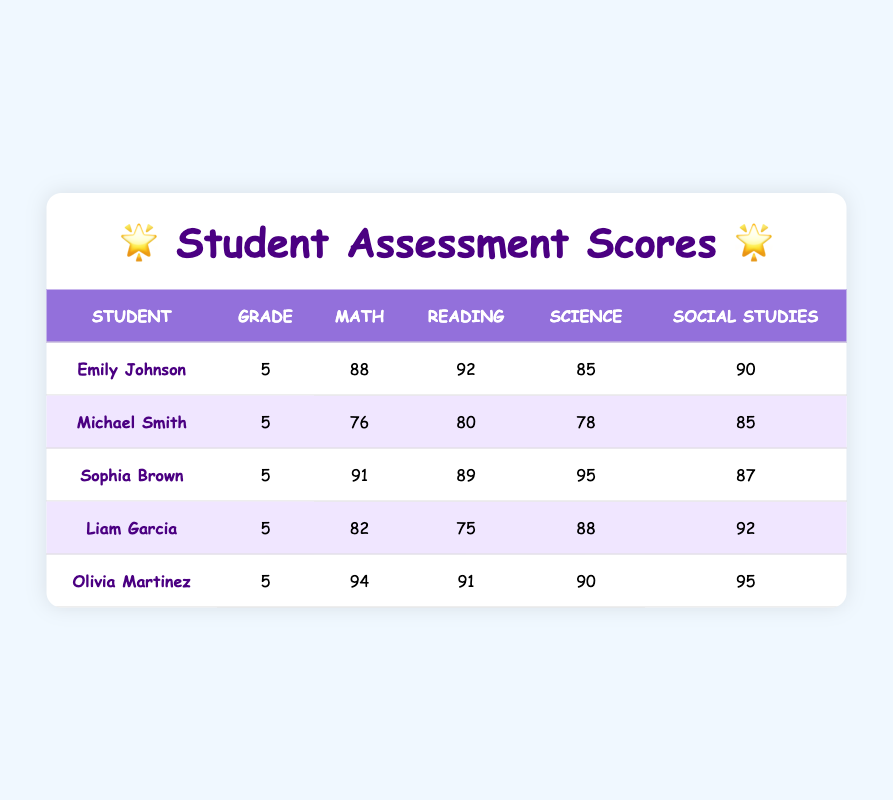What is the highest MathScore in the table? By inspecting the MathScore column, the highest score is found by comparing the scores of each student. Emily Johnson has a score of 88, Michael Smith has 76, Sophia Brown has 91, Liam Garcia has 82, and Olivia Martinez has 94. Therefore, the highest score is 94 from Olivia Martinez.
Answer: 94 Who scored the lowest in Reading? Looking at the ReadingScore column, we need to identify the student with the lowest score. The scores are: Emily Johnson 92, Michael Smith 80, Sophia Brown 89, Liam Garcia 75, and Olivia Martinez 91. The lowest score is 75 from Liam Garcia.
Answer: 75 What is the average ScienceScore for the students? To calculate the average ScienceScore, we first sum the individual scores: 85 + 78 + 95 + 88 + 90 = 436. Then, we divide this sum by the total number of students (5). So, 436 / 5 = 87.2.
Answer: 87.2 Did Olivia Martinez score higher in Social Studies than she did in Math? Checking the scores, Olivia Martinez scored 94 in Math and 95 in Social Studies. Since 95 is greater than 94, the statement is true.
Answer: Yes Which student has the best overall performance based on total scores? To find the best overall performer, we will sum the scores for each student: Emily Johnson (88+92+85+90=355), Michael Smith (76+80+78+85=319), Sophia Brown (91+89+95+87=362), Liam Garcia (82+75+88+92=337), and Olivia Martinez (94+91+90+95=370). The highest total comes from Olivia Martinez with 370.
Answer: Olivia Martinez What is the difference between the highest and lowest MathScores? To determine this difference, we first identify the highest MathScore (94 from Olivia Martinez) and the lowest MathScore (76 from Michael Smith). Subtracting the lowest from the highest gives us 94 - 76 = 18.
Answer: 18 Which subject had the highest average score among the students? The averages for each subject are calculated as follows: Math (88+76+91+82+94)/5 = 86.2, Reading (92+80+89+75+91)/5 = 85.4, Science (85+78+95+88+90)/5 = 87.2, Social Studies (90+85+87+92+95)/5 = 89.8. The highest average is for Social Studies at 89.8.
Answer: Social Studies Did all students score above 75 in Science? Looking at each student's ScienceScore, we see: Emily Johnson 85, Michael Smith 78, Sophia Brown 95, Liam Garcia 88, and Olivia Martinez 90. All scores are above 75, so the statement is true.
Answer: Yes 